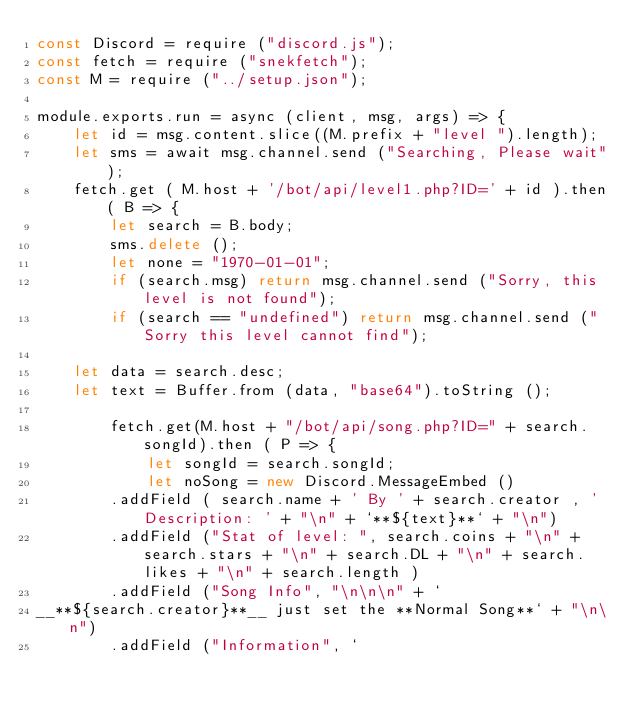Convert code to text. <code><loc_0><loc_0><loc_500><loc_500><_JavaScript_>const Discord = require ("discord.js");
const fetch = require ("snekfetch");
const M = require ("../setup.json");

module.exports.run = async (client, msg, args) => {
	let id = msg.content.slice((M.prefix + "level ").length);
	let sms = await msg.channel.send ("Searching, Please wait");
	fetch.get ( M.host + '/bot/api/level1.php?ID=' + id ).then( B => {
		let search = B.body;
		sms.delete ();
		let none = "1970-01-01";
		if (search.msg) return msg.channel.send ("Sorry, this level is not found");
		if (search == "undefined") return msg.channel.send ("Sorry this level cannot find");

	let data = search.desc;
	let text = Buffer.from (data, "base64").toString ();
	
		fetch.get(M.host + "/bot/api/song.php?ID=" + search.songId).then ( P => {
			let songId = search.songId;
			let noSong = new Discord.MessageEmbed ()
		.addField ( search.name + ' By ' + search.creator , 'Description: ' + "\n" + `**${text}**` + "\n")
		.addField ("Stat of level: ", search.coins + "\n" + search.stars + "\n" + search.DL + "\n" + search.likes + "\n" + search.length )
        .addField ("Song Info", "\n\n\n" + `
__**${search.creator}**__ just set the **Normal Song**` + "\n\n")
        .addField ("Information", `</code> 